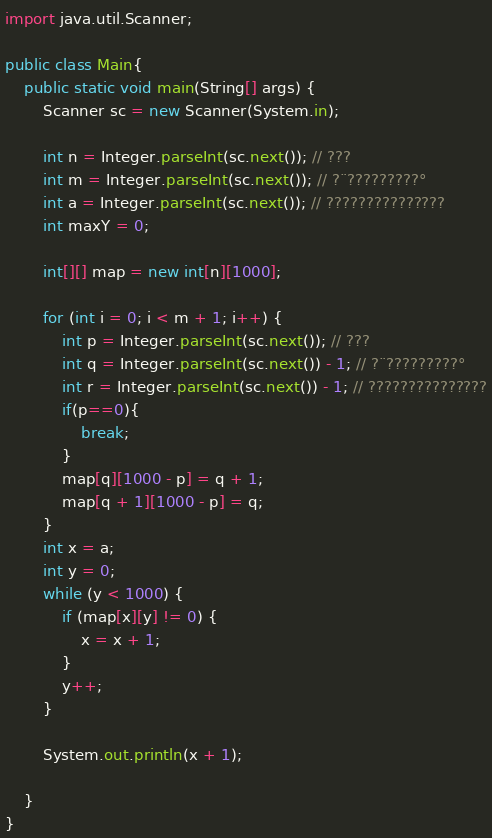<code> <loc_0><loc_0><loc_500><loc_500><_Java_>import java.util.Scanner;

public class Main{
	public static void main(String[] args) {
		Scanner sc = new Scanner(System.in);

		int n = Integer.parseInt(sc.next()); // ???
		int m = Integer.parseInt(sc.next()); // ?¨?????????°
		int a = Integer.parseInt(sc.next()); // ???????????????
		int maxY = 0;

		int[][] map = new int[n][1000];

		for (int i = 0; i < m + 1; i++) {
			int p = Integer.parseInt(sc.next()); // ???
			int q = Integer.parseInt(sc.next()) - 1; // ?¨?????????°
			int r = Integer.parseInt(sc.next()) - 1; // ???????????????
			if(p==0){
				break;
			}
			map[q][1000 - p] = q + 1;
			map[q + 1][1000 - p] = q;
		}
		int x = a;
		int y = 0;
		while (y < 1000) {
			if (map[x][y] != 0) {
				x = x + 1;
			}
			y++;
		}

		System.out.println(x + 1);

	}
}</code> 